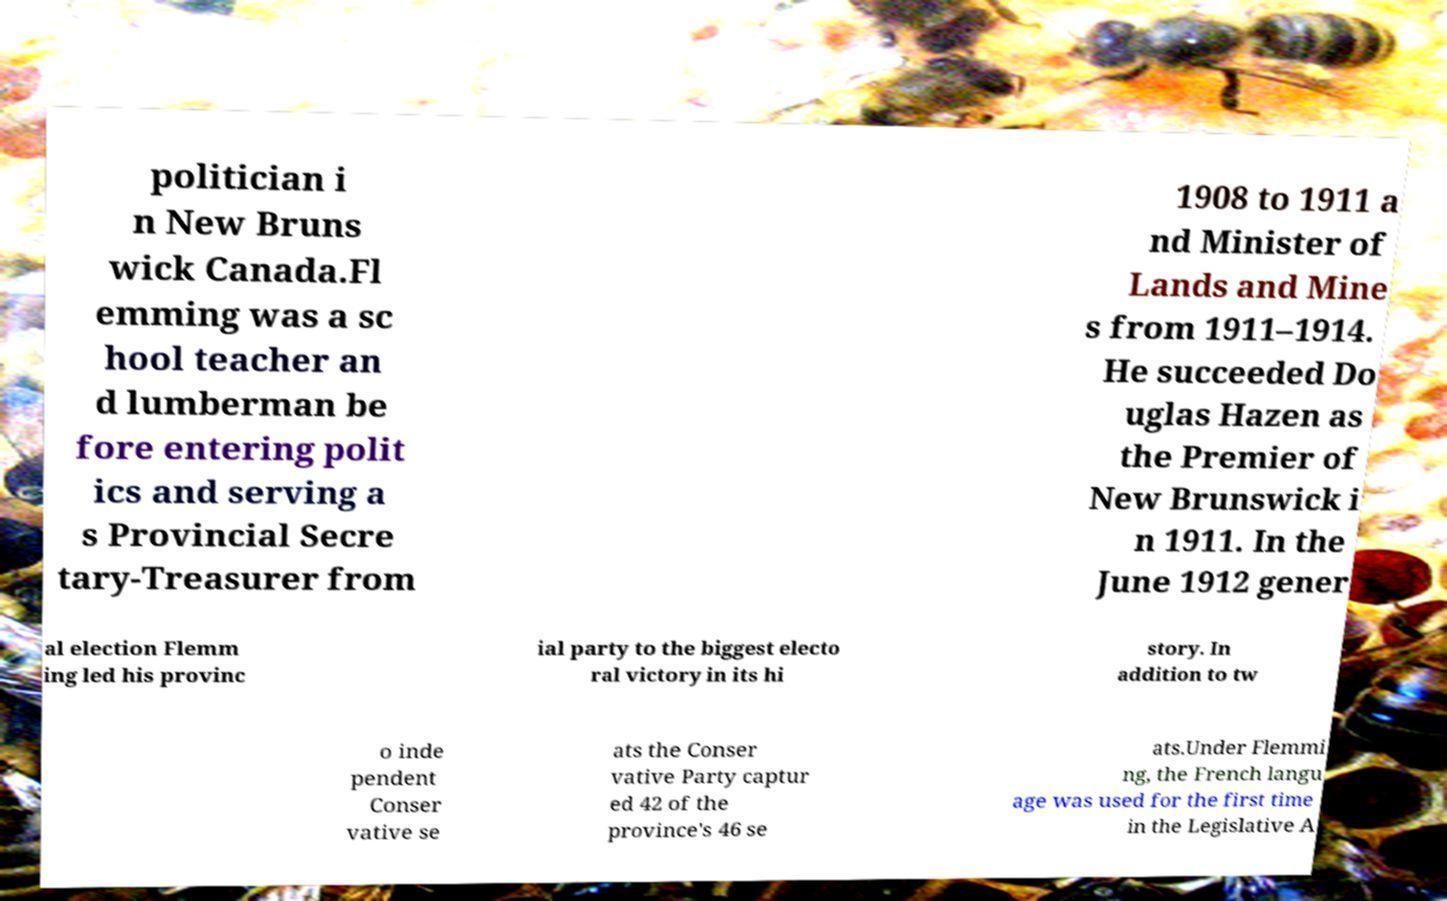Can you read and provide the text displayed in the image?This photo seems to have some interesting text. Can you extract and type it out for me? politician i n New Bruns wick Canada.Fl emming was a sc hool teacher an d lumberman be fore entering polit ics and serving a s Provincial Secre tary-Treasurer from 1908 to 1911 a nd Minister of Lands and Mine s from 1911–1914. He succeeded Do uglas Hazen as the Premier of New Brunswick i n 1911. In the June 1912 gener al election Flemm ing led his provinc ial party to the biggest electo ral victory in its hi story. In addition to tw o inde pendent Conser vative se ats the Conser vative Party captur ed 42 of the province's 46 se ats.Under Flemmi ng, the French langu age was used for the first time in the Legislative A 